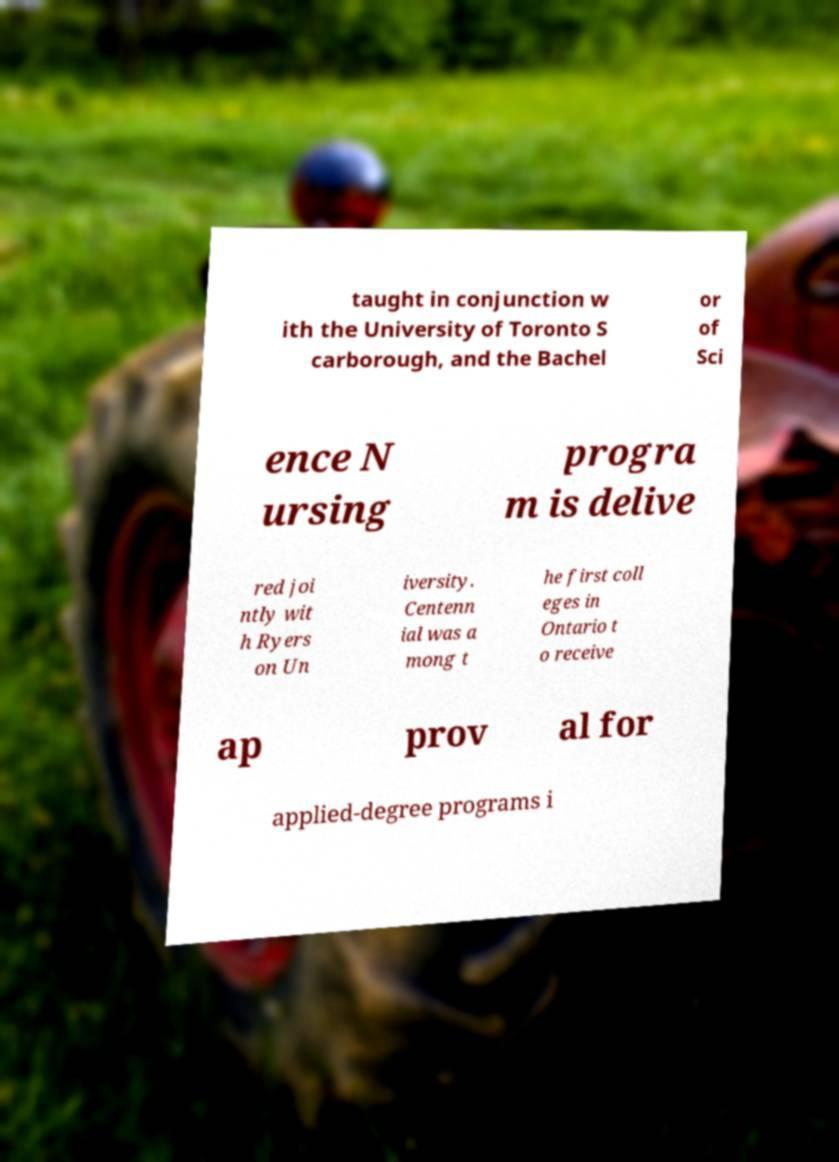There's text embedded in this image that I need extracted. Can you transcribe it verbatim? taught in conjunction w ith the University of Toronto S carborough, and the Bachel or of Sci ence N ursing progra m is delive red joi ntly wit h Ryers on Un iversity. Centenn ial was a mong t he first coll eges in Ontario t o receive ap prov al for applied-degree programs i 